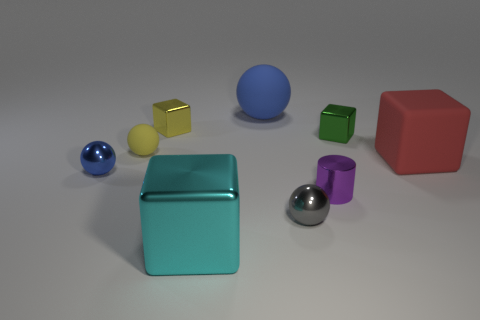Subtract all large balls. How many balls are left? 3 Subtract all cyan cubes. How many cubes are left? 3 Subtract 3 blocks. How many blocks are left? 1 Subtract all brown spheres. How many cyan cubes are left? 1 Add 1 tiny metal cylinders. How many objects exist? 10 Subtract all cylinders. How many objects are left? 8 Subtract all large purple shiny blocks. Subtract all tiny rubber things. How many objects are left? 8 Add 2 big red objects. How many big red objects are left? 3 Add 6 tiny purple objects. How many tiny purple objects exist? 7 Subtract 1 gray balls. How many objects are left? 8 